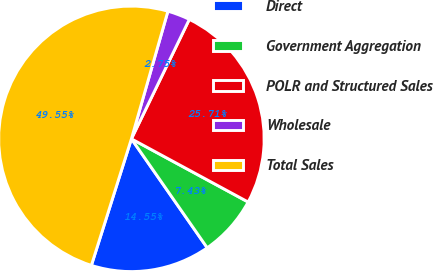Convert chart to OTSL. <chart><loc_0><loc_0><loc_500><loc_500><pie_chart><fcel>Direct<fcel>Government Aggregation<fcel>POLR and Structured Sales<fcel>Wholesale<fcel>Total Sales<nl><fcel>14.55%<fcel>7.43%<fcel>25.71%<fcel>2.75%<fcel>49.55%<nl></chart> 